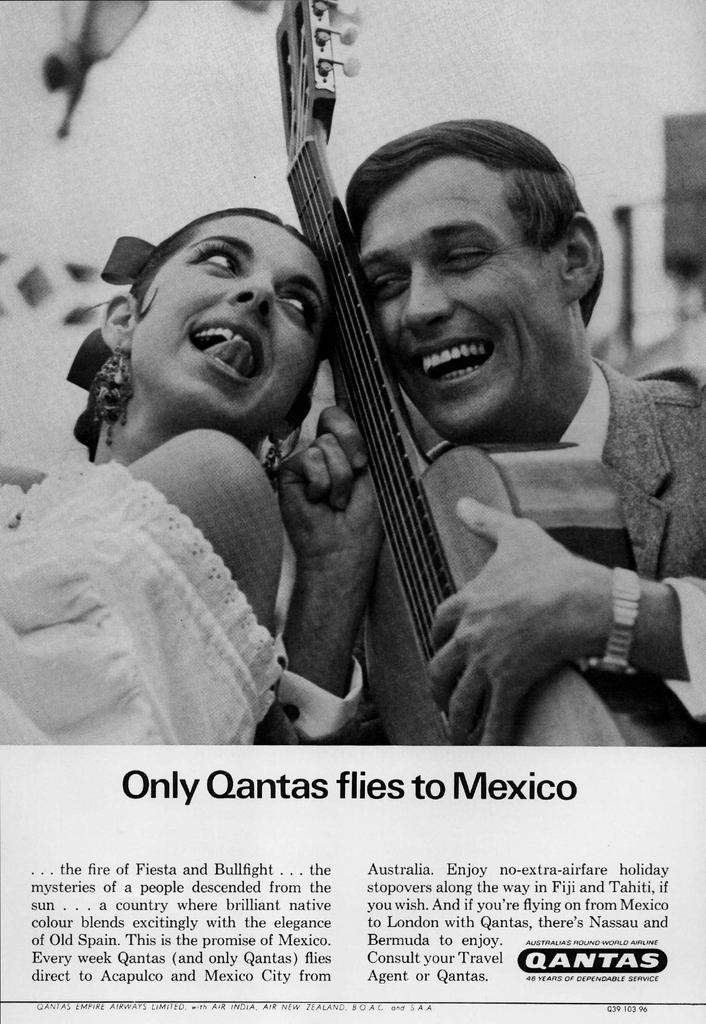Describe this image in one or two sentences. This image consists of texts which is at the bottom. In the center there is a man holding a musical instrument in his hand and smiling and on the left side there is a woman wearing a white colour dress and smiling. In the background there is a wall which is white in colour. 